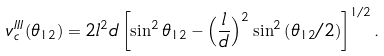<formula> <loc_0><loc_0><loc_500><loc_500>v _ { c } ^ { I I I } ( \theta _ { 1 2 } ) = 2 l ^ { 2 } d \left [ \sin ^ { 2 } \theta _ { 1 2 } - \left ( \frac { l } { d } \right ) ^ { 2 } \sin ^ { 2 } \left ( \theta _ { 1 2 } / 2 \right ) \right ] ^ { 1 / 2 } .</formula> 